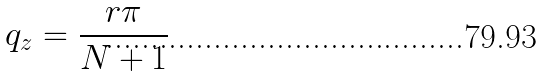<formula> <loc_0><loc_0><loc_500><loc_500>q _ { z } = \frac { r \pi } { N + 1 }</formula> 